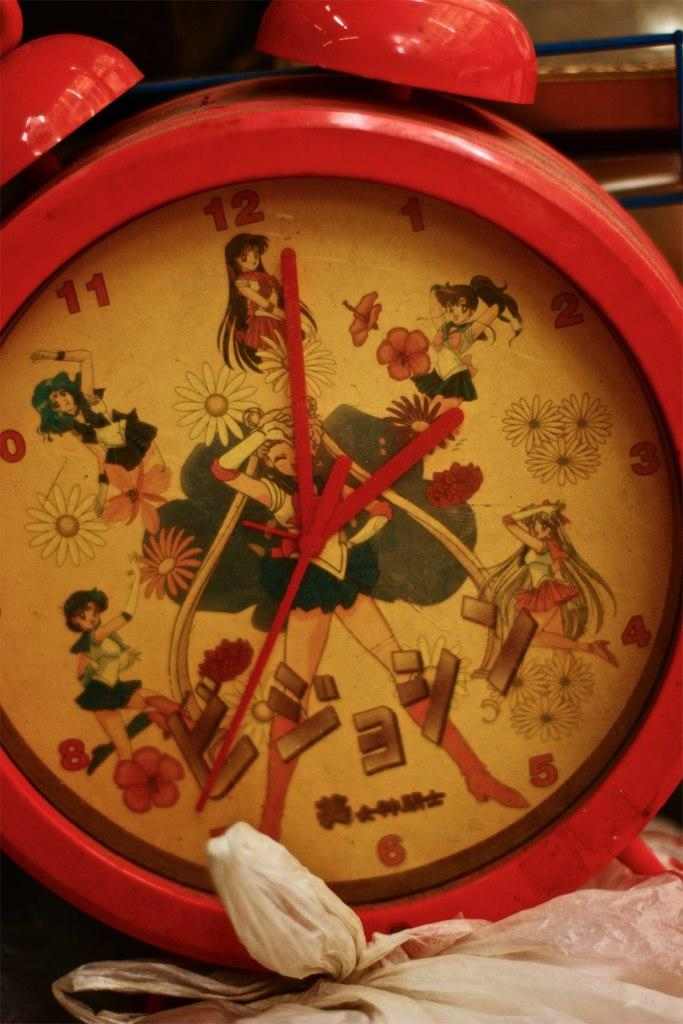<image>
Provide a brief description of the given image. An alarm clock features a cartoon woman whose feet stand on either side of the number 6. 